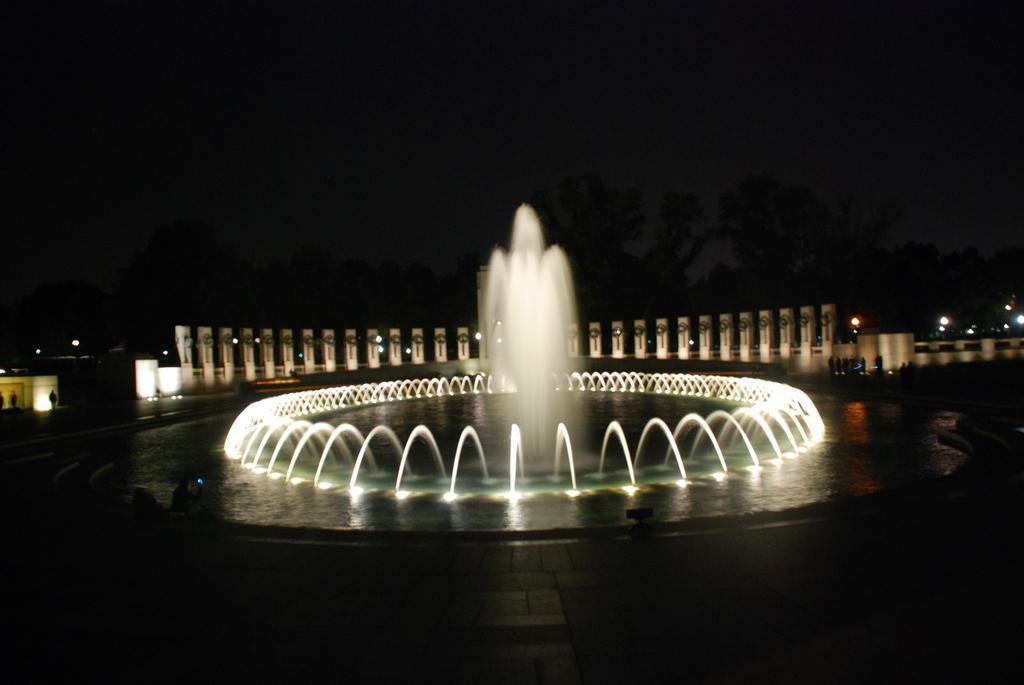Can you describe this image briefly? There are fountains with pipe. In the back there are pillars, trees and sky. And it is dark in the background. 